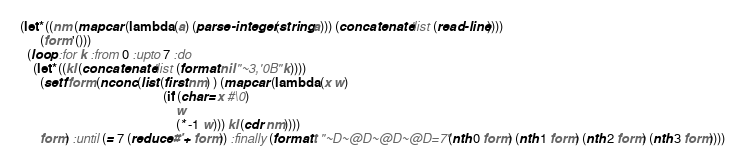<code> <loc_0><loc_0><loc_500><loc_500><_Lisp_>(let* ((nm (mapcar (lambda (a) (parse-integer (string a))) (concatenate 'list (read-line))))
      (form '()))
  (loop :for k :from 0 :upto 7 :do
    (let* ((kl (concatenate 'list (format nil "~3,'0B" k))))
      (setf form (nconc (list (first nm) ) (mapcar (lambda (x w)
                                            (if (char= x #\0)
                                                w
                                                (* -1 w))) kl (cdr nm))))
      form) :until (= 7 (reduce #'+ form)) :finally (format t "~D~@D~@D~@D=7" (nth 0 form) (nth 1 form) (nth 2 form) (nth 3 form))))</code> 